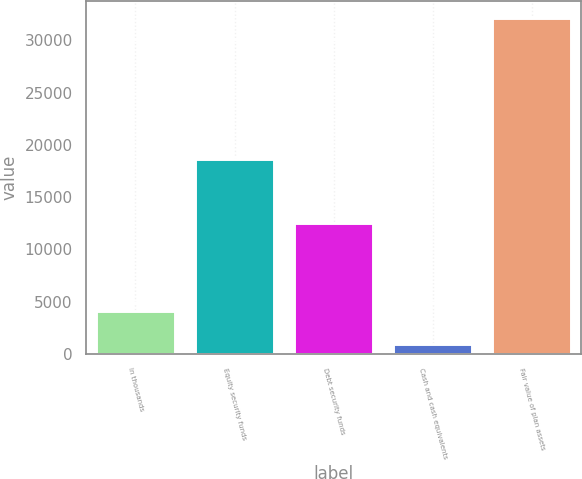<chart> <loc_0><loc_0><loc_500><loc_500><bar_chart><fcel>In thousands<fcel>Equity security funds<fcel>Debt security funds<fcel>Cash and cash equivalents<fcel>Fair value of plan assets<nl><fcel>4084.9<fcel>18655<fcel>12544<fcel>965<fcel>32164<nl></chart> 